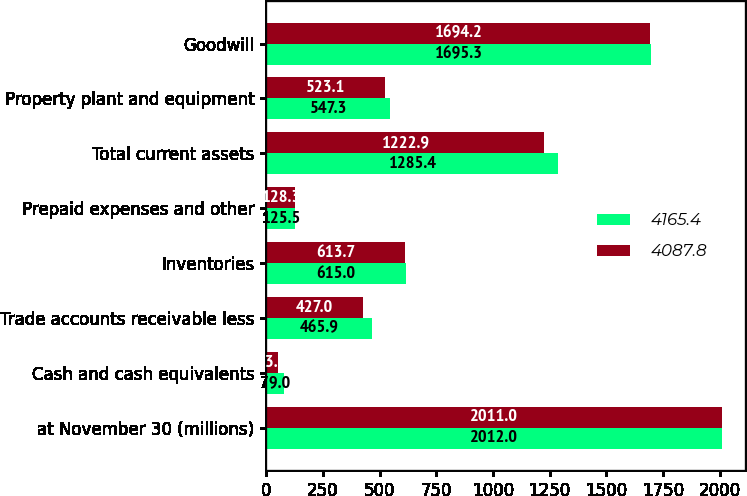<chart> <loc_0><loc_0><loc_500><loc_500><stacked_bar_chart><ecel><fcel>at November 30 (millions)<fcel>Cash and cash equivalents<fcel>Trade accounts receivable less<fcel>Inventories<fcel>Prepaid expenses and other<fcel>Total current assets<fcel>Property plant and equipment<fcel>Goodwill<nl><fcel>4165.4<fcel>2012<fcel>79<fcel>465.9<fcel>615<fcel>125.5<fcel>1285.4<fcel>547.3<fcel>1695.3<nl><fcel>4087.8<fcel>2011<fcel>53.9<fcel>427<fcel>613.7<fcel>128.3<fcel>1222.9<fcel>523.1<fcel>1694.2<nl></chart> 